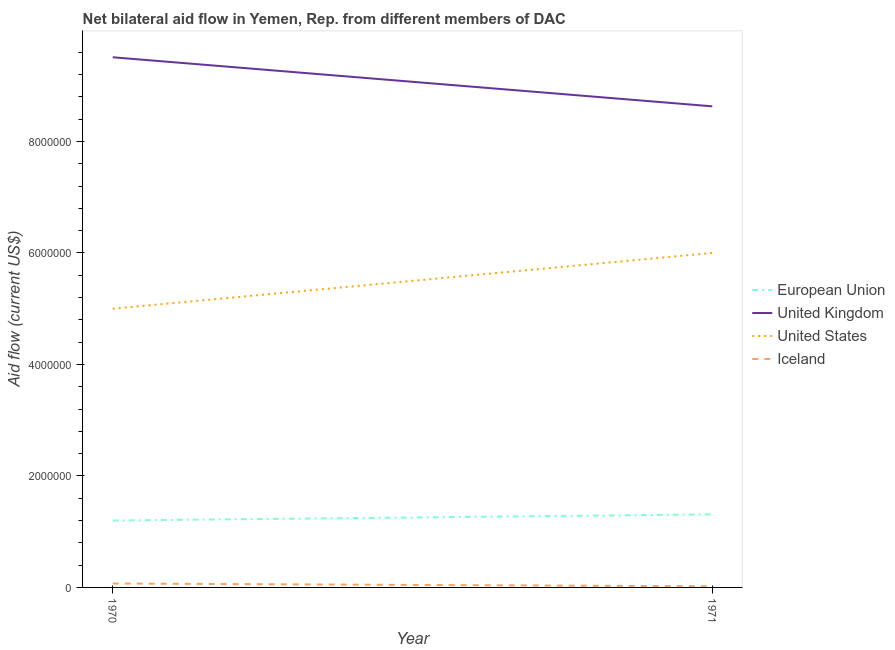Does the line corresponding to amount of aid given by uk intersect with the line corresponding to amount of aid given by eu?
Ensure brevity in your answer.  No. Is the number of lines equal to the number of legend labels?
Offer a very short reply. Yes. What is the amount of aid given by uk in 1970?
Offer a terse response. 9.51e+06. Across all years, what is the maximum amount of aid given by us?
Make the answer very short. 6.00e+06. Across all years, what is the minimum amount of aid given by us?
Offer a very short reply. 5.00e+06. In which year was the amount of aid given by eu maximum?
Offer a very short reply. 1971. What is the total amount of aid given by uk in the graph?
Give a very brief answer. 1.81e+07. What is the difference between the amount of aid given by us in 1970 and that in 1971?
Provide a succinct answer. -1.00e+06. What is the difference between the amount of aid given by eu in 1971 and the amount of aid given by uk in 1970?
Keep it short and to the point. -8.20e+06. What is the average amount of aid given by uk per year?
Offer a terse response. 9.07e+06. In the year 1970, what is the difference between the amount of aid given by uk and amount of aid given by iceland?
Provide a short and direct response. 9.44e+06. What is the ratio of the amount of aid given by us in 1970 to that in 1971?
Make the answer very short. 0.83. Is the amount of aid given by eu in 1970 less than that in 1971?
Make the answer very short. Yes. In how many years, is the amount of aid given by eu greater than the average amount of aid given by eu taken over all years?
Your answer should be compact. 1. Is it the case that in every year, the sum of the amount of aid given by eu and amount of aid given by uk is greater than the amount of aid given by us?
Give a very brief answer. Yes. What is the difference between two consecutive major ticks on the Y-axis?
Give a very brief answer. 2.00e+06. Are the values on the major ticks of Y-axis written in scientific E-notation?
Provide a short and direct response. No. Where does the legend appear in the graph?
Your response must be concise. Center right. How many legend labels are there?
Offer a very short reply. 4. What is the title of the graph?
Your answer should be compact. Net bilateral aid flow in Yemen, Rep. from different members of DAC. Does "Mammal species" appear as one of the legend labels in the graph?
Give a very brief answer. No. What is the label or title of the X-axis?
Give a very brief answer. Year. What is the label or title of the Y-axis?
Provide a short and direct response. Aid flow (current US$). What is the Aid flow (current US$) in European Union in 1970?
Provide a short and direct response. 1.20e+06. What is the Aid flow (current US$) of United Kingdom in 1970?
Your response must be concise. 9.51e+06. What is the Aid flow (current US$) of Iceland in 1970?
Make the answer very short. 7.00e+04. What is the Aid flow (current US$) of European Union in 1971?
Offer a terse response. 1.31e+06. What is the Aid flow (current US$) in United Kingdom in 1971?
Keep it short and to the point. 8.63e+06. What is the Aid flow (current US$) of United States in 1971?
Your answer should be compact. 6.00e+06. What is the Aid flow (current US$) in Iceland in 1971?
Offer a terse response. 2.00e+04. Across all years, what is the maximum Aid flow (current US$) of European Union?
Your response must be concise. 1.31e+06. Across all years, what is the maximum Aid flow (current US$) of United Kingdom?
Keep it short and to the point. 9.51e+06. Across all years, what is the maximum Aid flow (current US$) in United States?
Make the answer very short. 6.00e+06. Across all years, what is the minimum Aid flow (current US$) of European Union?
Keep it short and to the point. 1.20e+06. Across all years, what is the minimum Aid flow (current US$) in United Kingdom?
Your answer should be very brief. 8.63e+06. What is the total Aid flow (current US$) of European Union in the graph?
Make the answer very short. 2.51e+06. What is the total Aid flow (current US$) in United Kingdom in the graph?
Your answer should be compact. 1.81e+07. What is the total Aid flow (current US$) of United States in the graph?
Offer a very short reply. 1.10e+07. What is the total Aid flow (current US$) of Iceland in the graph?
Your response must be concise. 9.00e+04. What is the difference between the Aid flow (current US$) in United Kingdom in 1970 and that in 1971?
Ensure brevity in your answer.  8.80e+05. What is the difference between the Aid flow (current US$) of United States in 1970 and that in 1971?
Give a very brief answer. -1.00e+06. What is the difference between the Aid flow (current US$) of European Union in 1970 and the Aid flow (current US$) of United Kingdom in 1971?
Offer a terse response. -7.43e+06. What is the difference between the Aid flow (current US$) of European Union in 1970 and the Aid flow (current US$) of United States in 1971?
Make the answer very short. -4.80e+06. What is the difference between the Aid flow (current US$) in European Union in 1970 and the Aid flow (current US$) in Iceland in 1971?
Make the answer very short. 1.18e+06. What is the difference between the Aid flow (current US$) in United Kingdom in 1970 and the Aid flow (current US$) in United States in 1971?
Your answer should be compact. 3.51e+06. What is the difference between the Aid flow (current US$) of United Kingdom in 1970 and the Aid flow (current US$) of Iceland in 1971?
Make the answer very short. 9.49e+06. What is the difference between the Aid flow (current US$) of United States in 1970 and the Aid flow (current US$) of Iceland in 1971?
Make the answer very short. 4.98e+06. What is the average Aid flow (current US$) of European Union per year?
Keep it short and to the point. 1.26e+06. What is the average Aid flow (current US$) in United Kingdom per year?
Your response must be concise. 9.07e+06. What is the average Aid flow (current US$) in United States per year?
Offer a very short reply. 5.50e+06. What is the average Aid flow (current US$) of Iceland per year?
Provide a short and direct response. 4.50e+04. In the year 1970, what is the difference between the Aid flow (current US$) of European Union and Aid flow (current US$) of United Kingdom?
Ensure brevity in your answer.  -8.31e+06. In the year 1970, what is the difference between the Aid flow (current US$) in European Union and Aid flow (current US$) in United States?
Your response must be concise. -3.80e+06. In the year 1970, what is the difference between the Aid flow (current US$) of European Union and Aid flow (current US$) of Iceland?
Your response must be concise. 1.13e+06. In the year 1970, what is the difference between the Aid flow (current US$) in United Kingdom and Aid flow (current US$) in United States?
Ensure brevity in your answer.  4.51e+06. In the year 1970, what is the difference between the Aid flow (current US$) of United Kingdom and Aid flow (current US$) of Iceland?
Provide a succinct answer. 9.44e+06. In the year 1970, what is the difference between the Aid flow (current US$) in United States and Aid flow (current US$) in Iceland?
Your answer should be very brief. 4.93e+06. In the year 1971, what is the difference between the Aid flow (current US$) in European Union and Aid flow (current US$) in United Kingdom?
Your answer should be compact. -7.32e+06. In the year 1971, what is the difference between the Aid flow (current US$) of European Union and Aid flow (current US$) of United States?
Make the answer very short. -4.69e+06. In the year 1971, what is the difference between the Aid flow (current US$) of European Union and Aid flow (current US$) of Iceland?
Your response must be concise. 1.29e+06. In the year 1971, what is the difference between the Aid flow (current US$) in United Kingdom and Aid flow (current US$) in United States?
Your answer should be very brief. 2.63e+06. In the year 1971, what is the difference between the Aid flow (current US$) in United Kingdom and Aid flow (current US$) in Iceland?
Provide a short and direct response. 8.61e+06. In the year 1971, what is the difference between the Aid flow (current US$) in United States and Aid flow (current US$) in Iceland?
Offer a very short reply. 5.98e+06. What is the ratio of the Aid flow (current US$) of European Union in 1970 to that in 1971?
Give a very brief answer. 0.92. What is the ratio of the Aid flow (current US$) of United Kingdom in 1970 to that in 1971?
Ensure brevity in your answer.  1.1. What is the difference between the highest and the second highest Aid flow (current US$) of United Kingdom?
Your answer should be compact. 8.80e+05. What is the difference between the highest and the second highest Aid flow (current US$) of Iceland?
Give a very brief answer. 5.00e+04. What is the difference between the highest and the lowest Aid flow (current US$) of United Kingdom?
Your answer should be compact. 8.80e+05. What is the difference between the highest and the lowest Aid flow (current US$) of United States?
Your answer should be very brief. 1.00e+06. What is the difference between the highest and the lowest Aid flow (current US$) of Iceland?
Make the answer very short. 5.00e+04. 